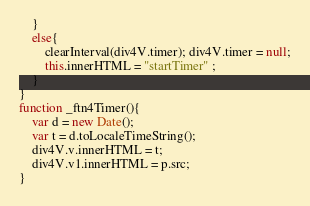Convert code to text. <code><loc_0><loc_0><loc_500><loc_500><_JavaScript_>	}
	else{
		clearInterval(div4V.timer); div4V.timer = null;
		this.innerHTML = "startTimer" ;
	}
}
function _ftn4Timer(){
    var d = new Date();
    var t = d.toLocaleTimeString();
    div4V.v.innerHTML = t;	
    div4V.v1.innerHTML = p.src;
}</code> 